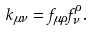<formula> <loc_0><loc_0><loc_500><loc_500>k _ { \mu \nu } = f _ { \mu \rho } f _ { \nu } ^ { \rho } .</formula> 